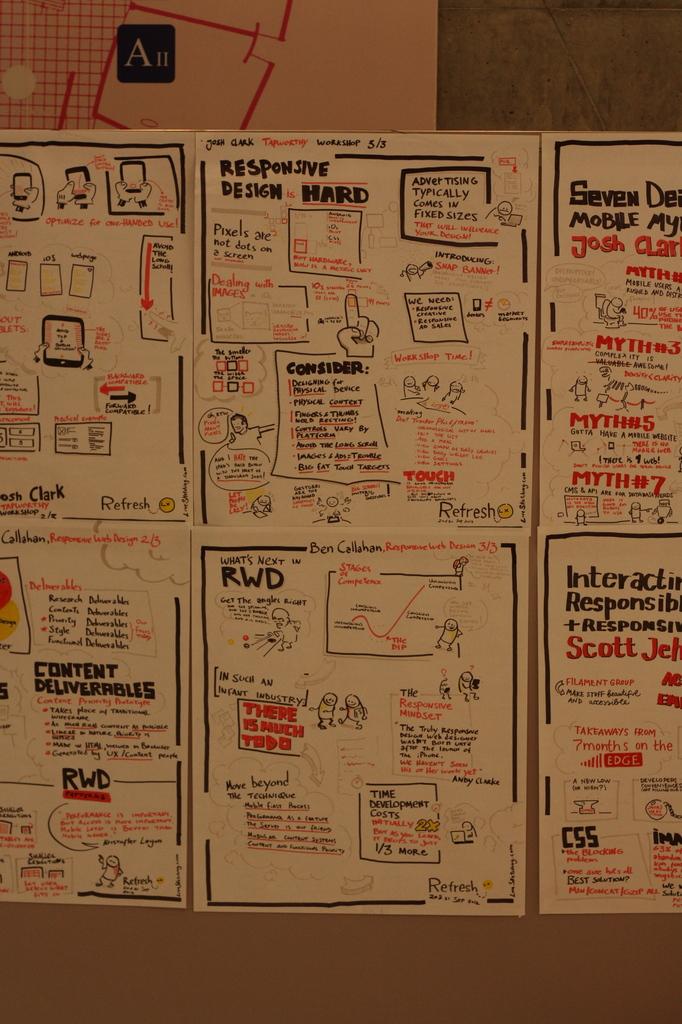According to the text, what is hard?
Give a very brief answer. Responsive design. What are the three capital black letters on the bottom center card?
Provide a short and direct response. Rwd. 